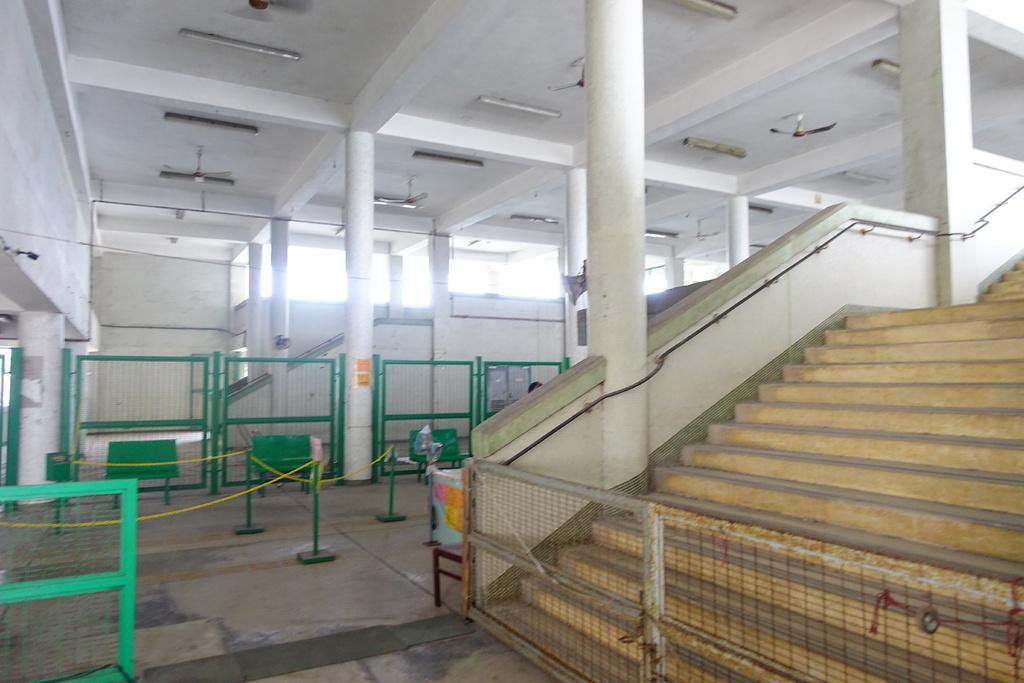Can you describe this image briefly? In this image we can see an inner view of a building containing some pillars, stairs, a fence, a container on a table, some poles with rope, a metal barricade, a wall, a roof with some tube lights and ceiling fans to it. 